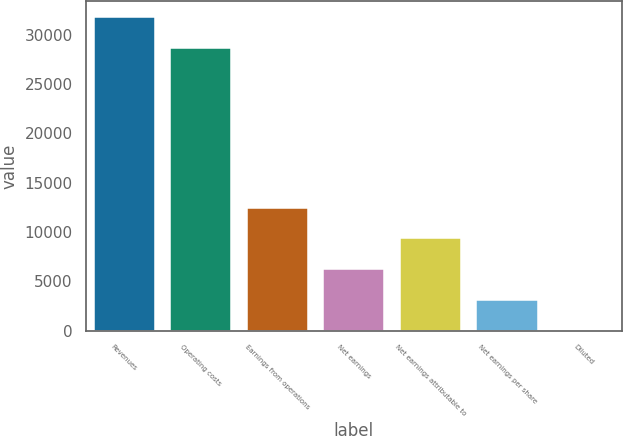Convert chart. <chart><loc_0><loc_0><loc_500><loc_500><bar_chart><fcel>Revenues<fcel>Operating costs<fcel>Earnings from operations<fcel>Net earnings<fcel>Net earnings attributable to<fcel>Net earnings per share<fcel>Diluted<nl><fcel>31776.6<fcel>28665<fcel>12447.6<fcel>6224.53<fcel>9336.09<fcel>3112.97<fcel>1.41<nl></chart> 